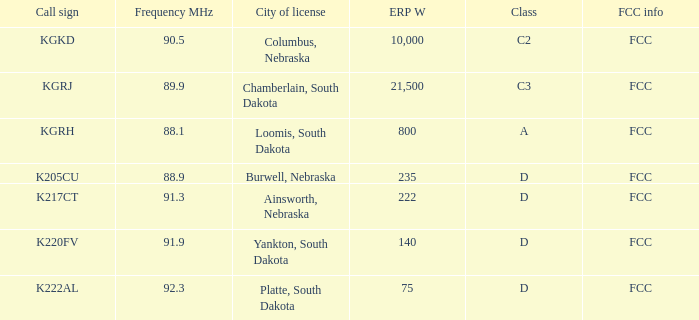What is the call sign associated with a 222 erp w? K217CT. 